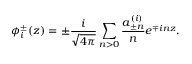<formula> <loc_0><loc_0><loc_500><loc_500>\phi _ { i } ^ { \pm } ( z ) = \pm \frac { i } { \sqrt { 4 \pi } } \sum _ { n > 0 } \frac { a _ { \pm n } ^ { ( i ) } } { n } e ^ { \mp i n z } .</formula> 